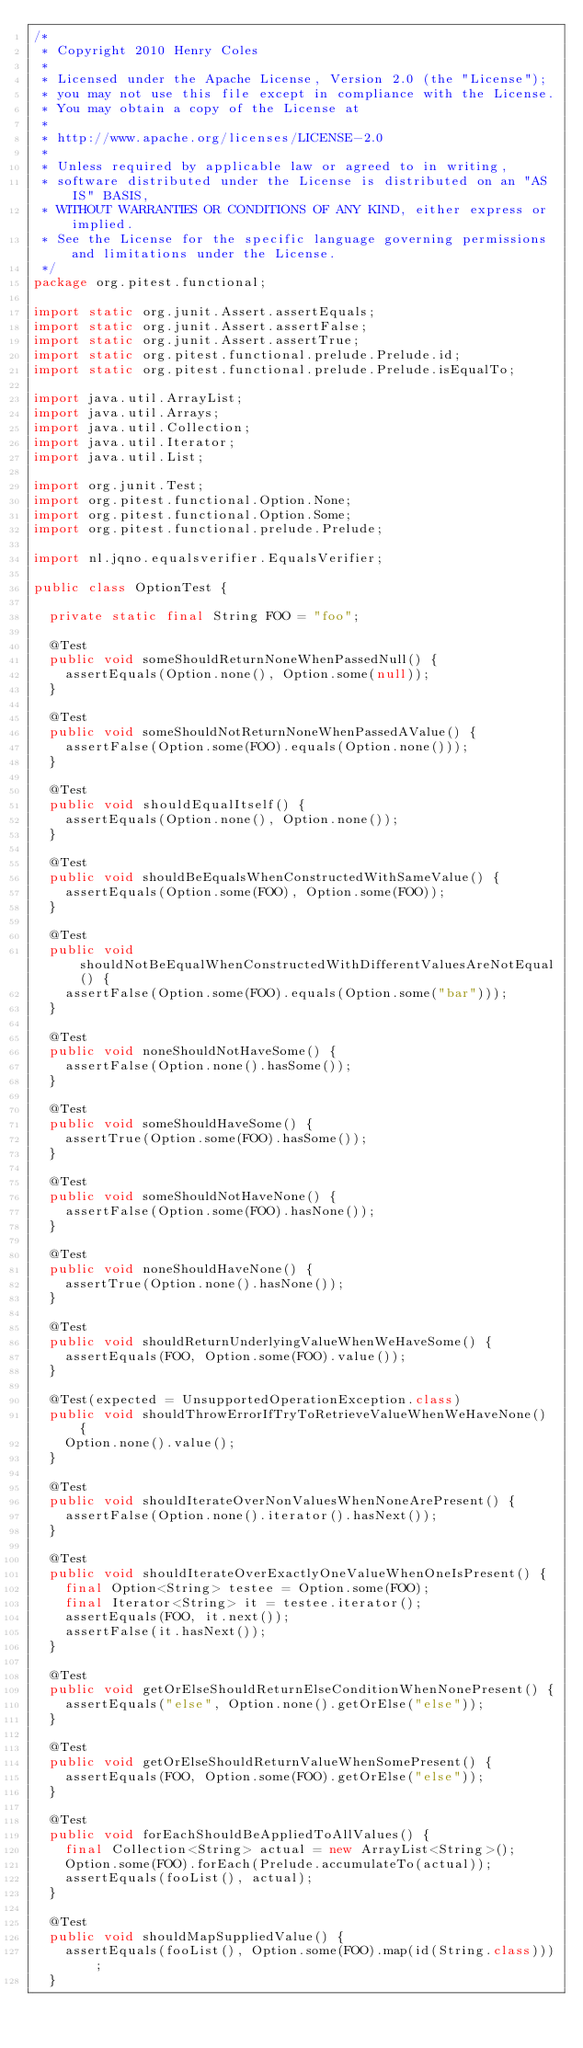<code> <loc_0><loc_0><loc_500><loc_500><_Java_>/*
 * Copyright 2010 Henry Coles
 *
 * Licensed under the Apache License, Version 2.0 (the "License");
 * you may not use this file except in compliance with the License.
 * You may obtain a copy of the License at
 *
 * http://www.apache.org/licenses/LICENSE-2.0
 *
 * Unless required by applicable law or agreed to in writing,
 * software distributed under the License is distributed on an "AS IS" BASIS,
 * WITHOUT WARRANTIES OR CONDITIONS OF ANY KIND, either express or implied.
 * See the License for the specific language governing permissions and limitations under the License.
 */
package org.pitest.functional;

import static org.junit.Assert.assertEquals;
import static org.junit.Assert.assertFalse;
import static org.junit.Assert.assertTrue;
import static org.pitest.functional.prelude.Prelude.id;
import static org.pitest.functional.prelude.Prelude.isEqualTo;

import java.util.ArrayList;
import java.util.Arrays;
import java.util.Collection;
import java.util.Iterator;
import java.util.List;

import org.junit.Test;
import org.pitest.functional.Option.None;
import org.pitest.functional.Option.Some;
import org.pitest.functional.prelude.Prelude;

import nl.jqno.equalsverifier.EqualsVerifier;

public class OptionTest {

  private static final String FOO = "foo";

  @Test
  public void someShouldReturnNoneWhenPassedNull() {
    assertEquals(Option.none(), Option.some(null));
  }

  @Test
  public void someShouldNotReturnNoneWhenPassedAValue() {
    assertFalse(Option.some(FOO).equals(Option.none()));
  }

  @Test
  public void shouldEqualItself() {
    assertEquals(Option.none(), Option.none());
  }

  @Test
  public void shouldBeEqualsWhenConstructedWithSameValue() {
    assertEquals(Option.some(FOO), Option.some(FOO));
  }

  @Test
  public void shouldNotBeEqualWhenConstructedWithDifferentValuesAreNotEqual() {
    assertFalse(Option.some(FOO).equals(Option.some("bar")));
  }

  @Test
  public void noneShouldNotHaveSome() {
    assertFalse(Option.none().hasSome());
  }

  @Test
  public void someShouldHaveSome() {
    assertTrue(Option.some(FOO).hasSome());
  }

  @Test
  public void someShouldNotHaveNone() {
    assertFalse(Option.some(FOO).hasNone());
  }

  @Test
  public void noneShouldHaveNone() {
    assertTrue(Option.none().hasNone());
  }

  @Test
  public void shouldReturnUnderlyingValueWhenWeHaveSome() {
    assertEquals(FOO, Option.some(FOO).value());
  }

  @Test(expected = UnsupportedOperationException.class)
  public void shouldThrowErrorIfTryToRetrieveValueWhenWeHaveNone() {
    Option.none().value();
  }

  @Test
  public void shouldIterateOverNonValuesWhenNoneArePresent() {
    assertFalse(Option.none().iterator().hasNext());
  }

  @Test
  public void shouldIterateOverExactlyOneValueWhenOneIsPresent() {
    final Option<String> testee = Option.some(FOO);
    final Iterator<String> it = testee.iterator();
    assertEquals(FOO, it.next());
    assertFalse(it.hasNext());
  }

  @Test
  public void getOrElseShouldReturnElseConditionWhenNonePresent() {
    assertEquals("else", Option.none().getOrElse("else"));
  }

  @Test
  public void getOrElseShouldReturnValueWhenSomePresent() {
    assertEquals(FOO, Option.some(FOO).getOrElse("else"));
  }

  @Test
  public void forEachShouldBeAppliedToAllValues() {
    final Collection<String> actual = new ArrayList<String>();
    Option.some(FOO).forEach(Prelude.accumulateTo(actual));
    assertEquals(fooList(), actual);
  }

  @Test
  public void shouldMapSuppliedValue() {
    assertEquals(fooList(), Option.some(FOO).map(id(String.class)));
  }
</code> 